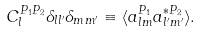Convert formula to latex. <formula><loc_0><loc_0><loc_500><loc_500>C _ { l } ^ { P _ { 1 } P _ { 2 } } \delta _ { l l ^ { \prime } } \delta _ { m m ^ { \prime } } \equiv \langle a _ { l m } ^ { P _ { 1 } } a _ { l ^ { \prime } m ^ { \prime } } ^ { * P _ { 2 } } \rangle .</formula> 